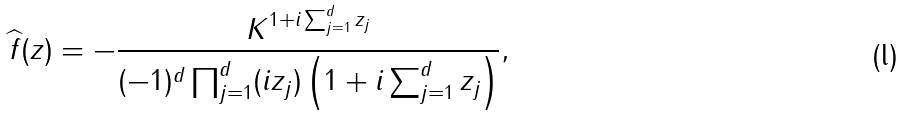<formula> <loc_0><loc_0><loc_500><loc_500>\widehat { f } ( z ) & = - \frac { K ^ { 1 + i \sum _ { j = 1 } ^ { d } z _ { j } } } { ( - 1 ) ^ { d } \prod _ { j = 1 } ^ { d } ( i z _ { j } ) \left ( 1 + i \sum _ { j = 1 } ^ { d } z _ { j } \right ) } ,</formula> 